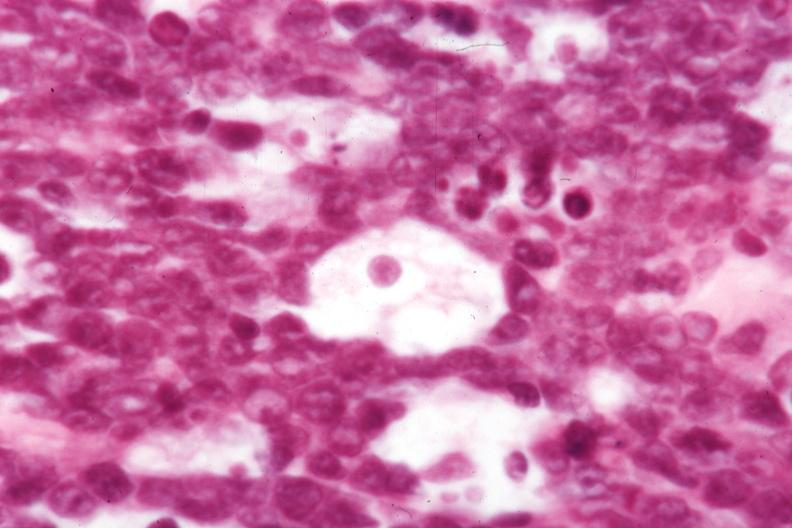how is not the best histology but morphology typical for?
Answer the question using a single word or phrase. Dx 